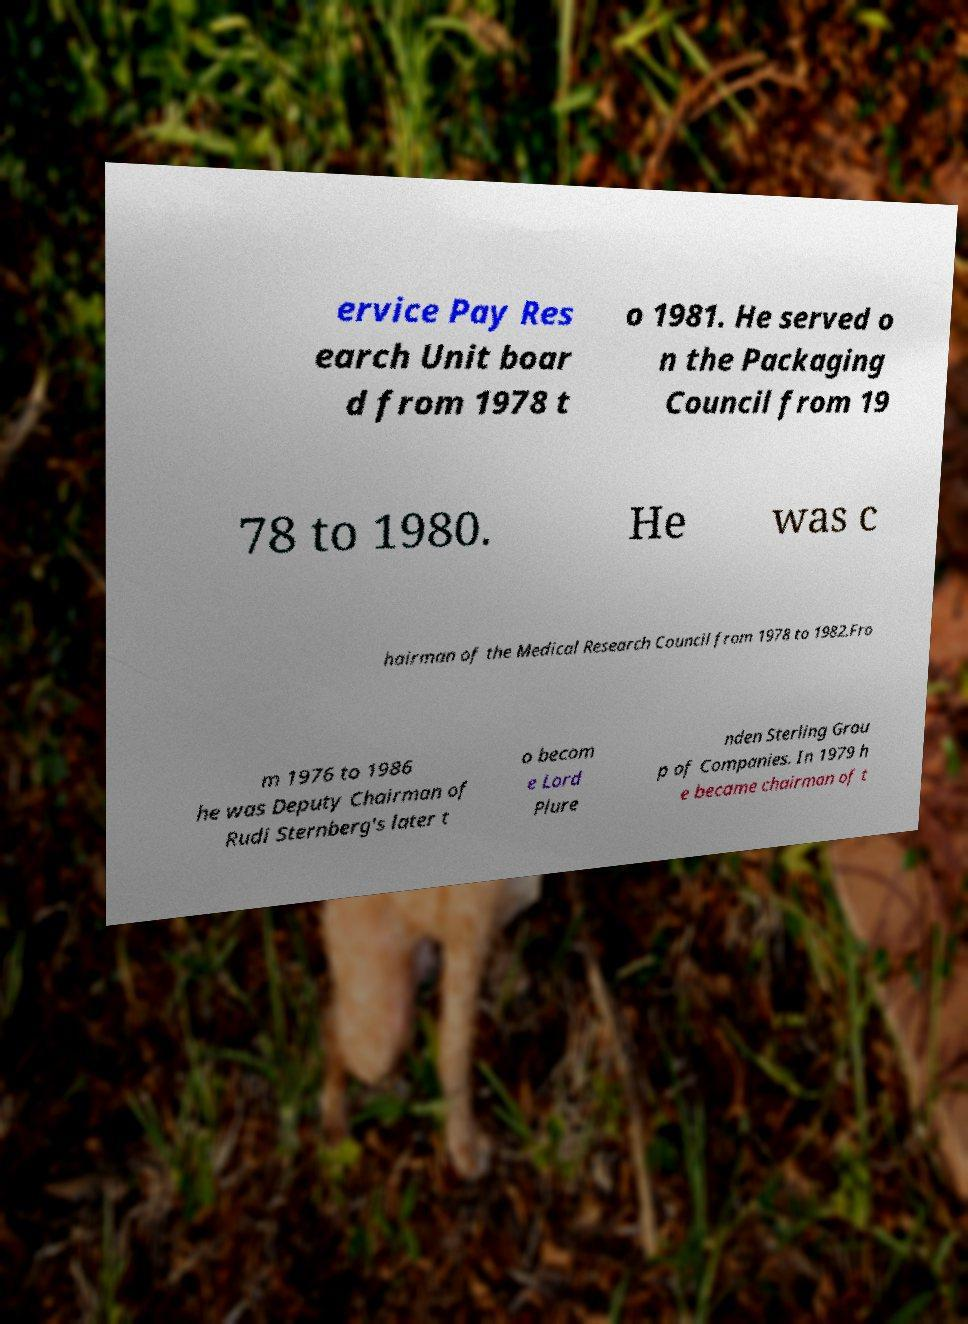For documentation purposes, I need the text within this image transcribed. Could you provide that? ervice Pay Res earch Unit boar d from 1978 t o 1981. He served o n the Packaging Council from 19 78 to 1980. He was c hairman of the Medical Research Council from 1978 to 1982.Fro m 1976 to 1986 he was Deputy Chairman of Rudi Sternberg's later t o becom e Lord Plure nden Sterling Grou p of Companies. In 1979 h e became chairman of t 